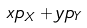<formula> <loc_0><loc_0><loc_500><loc_500>x p _ { X } + y p _ { Y }</formula> 